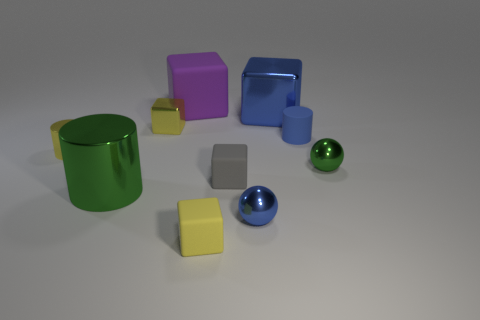How many yellow blocks are on the left side of the green cylinder?
Offer a terse response. 0. Are there any spheres that have the same size as the purple cube?
Ensure brevity in your answer.  No. Are there any big metal objects that have the same color as the big shiny cube?
Offer a very short reply. No. Is there any other thing that is the same size as the gray thing?
Keep it short and to the point. Yes. How many objects have the same color as the large shiny block?
Your answer should be very brief. 2. Is the color of the big shiny block the same as the ball that is in front of the gray thing?
Make the answer very short. Yes. How many objects are small blue metallic things or tiny things left of the small blue rubber cylinder?
Offer a very short reply. 5. There is a blue metal thing that is in front of the tiny cylinder left of the yellow metal cube; what is its size?
Provide a short and direct response. Small. Is the number of large matte objects that are behind the big green cylinder the same as the number of gray blocks that are right of the small yellow matte object?
Ensure brevity in your answer.  Yes. Are there any yellow cubes that are behind the metallic cylinder that is on the right side of the tiny yellow metal cylinder?
Keep it short and to the point. Yes. 